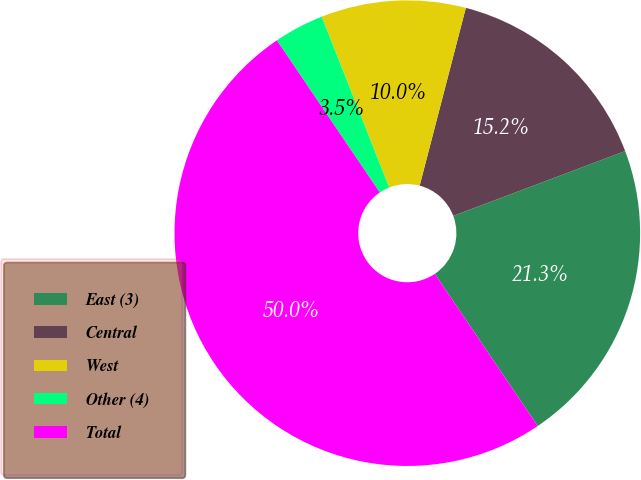Convert chart. <chart><loc_0><loc_0><loc_500><loc_500><pie_chart><fcel>East (3)<fcel>Central<fcel>West<fcel>Other (4)<fcel>Total<nl><fcel>21.27%<fcel>15.22%<fcel>10.04%<fcel>3.47%<fcel>50.0%<nl></chart> 